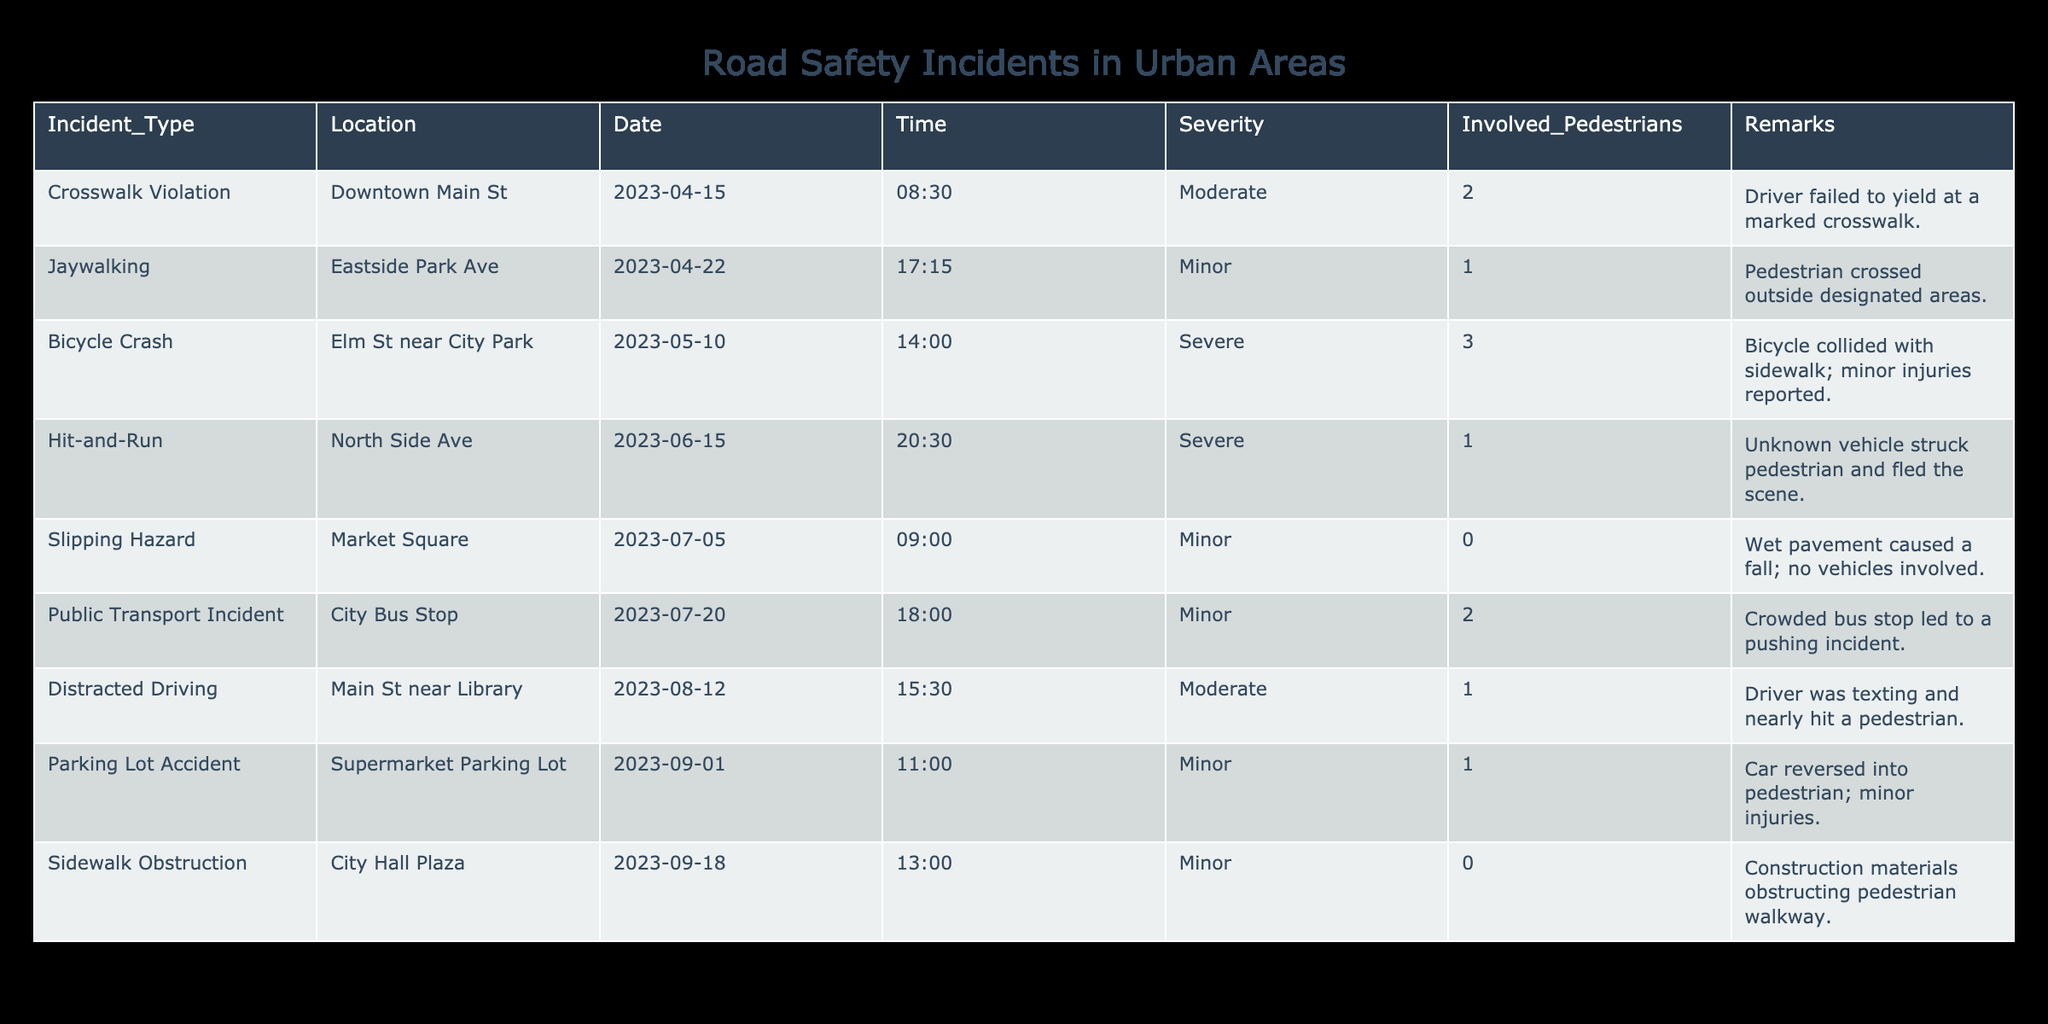What type of incident occurred at Downtown Main St? Referring to the table, the incident type listed for Downtown Main St is a "Crosswalk Violation."
Answer: Crosswalk Violation How many pedestrians were involved in the Hit-and-Run incident? The table displays that 1 pedestrian was involved in the Hit-and-Run incident.
Answer: 1 Were there any incidents with no pedestrians involved? Looking at the table, both the "Slipping Hazard" at Market Square and "Sidewalk Obstruction" at City Hall Plaza indicate 0 pedestrians involved, confirming there were incidents with no pedestrians involved.
Answer: Yes What was the most severe type of incident recorded? Among the incident types, "Bicycle Crash" and "Hit-and-Run" both have the severity rated as Severe. However, the contextual details suggest the "Hit-and-Run" was more alarming due to the unknown vehicle fleeing the scene.
Answer: Hit-and-Run If we sum all the involved pedestrians, what is the total count? Counting the involved pedestrians across all incidents: 2 (Crosswalk Violation) + 1 (Jaywalking) + 3 (Bicycle Crash) + 1 (Hit-and-Run) + 0 (Slipping Hazard) + 2 (Public Transport Incident) + 1 (Distracted Driving) + 1 (Parking Lot Accident) + 0 (Sidewalk Obstruction) gives us a total of 11 involved pedestrians.
Answer: 11 How many incidents occurred in June? From the table, there is only one incident listed in June, which is the "Hit-and-Run" on North Side Ave.
Answer: 1 Which location had the highest number of involved pedestrians in a single incident? The "Bicycle Crash" on Elm St near City Park involved the highest number of pedestrians at 3. This is the maximum count in the table.
Answer: Elm St near City Park Was any incident labeled as a "Slipping Hazard"? Yes, the "Slipping Hazard" is noted in the table for Market Square, confirming that this type of incident occurred.
Answer: Yes What percentage of total incidents were classified as "Minor" severity? To find this, there are 9 total incidents in the table. The Minor severity incidents are "Jaywalking," "Slipping Hazard," "Public Transport Incident," "Parking Lot Accident," and "Sidewalk Obstruction," totaling 5 incidents. Thus, (5/9)*100 = 55.56%, meaning approximately 56% of incidents were Minor.
Answer: 56% 